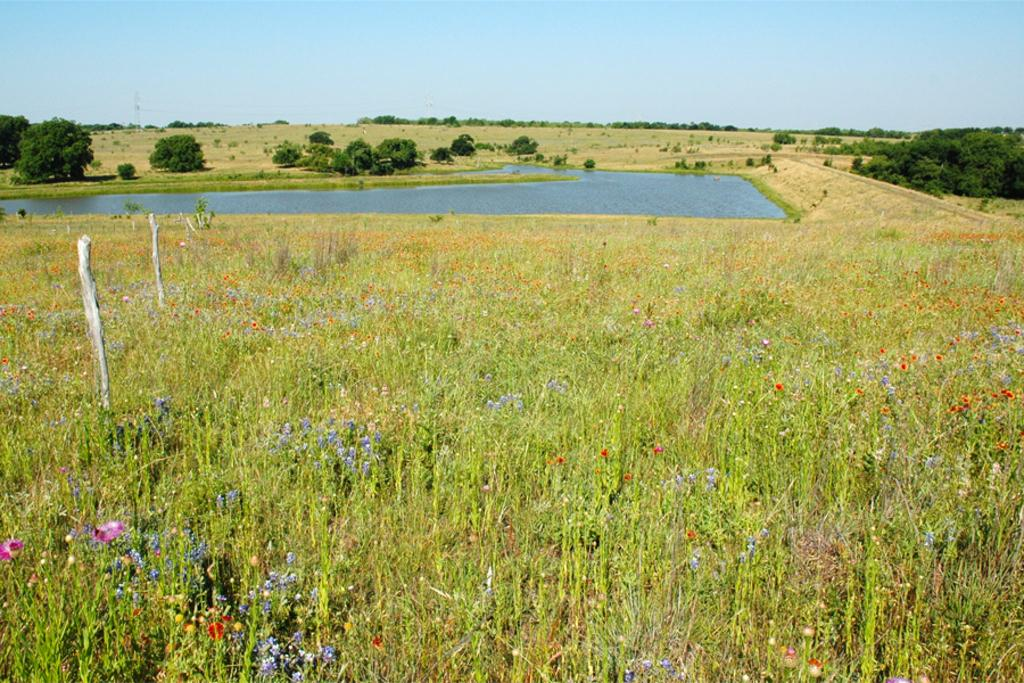What type of vegetation is present on the ground in the image? There are plants on the ground in the image. What can be seen in the middle of the image? There are trees and a pond in the middle of the image. What is visible in the background of the image? The sky is visible in the background of the image. Can you see any feet or dust in the image? No, there are no feet or dust present in the image. What type of skirt is hanging from the tree in the image? There is no skirt present in the image; it features plants, trees, a pond, and the sky. 